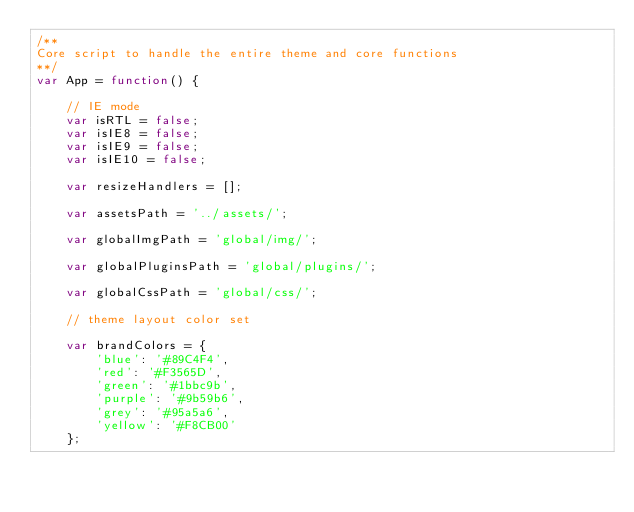<code> <loc_0><loc_0><loc_500><loc_500><_JavaScript_>/**
Core script to handle the entire theme and core functions
**/
var App = function() {

    // IE mode
    var isRTL = false;
    var isIE8 = false;
    var isIE9 = false;
    var isIE10 = false;

    var resizeHandlers = [];

    var assetsPath = '../assets/';

    var globalImgPath = 'global/img/';

    var globalPluginsPath = 'global/plugins/';

    var globalCssPath = 'global/css/';

    // theme layout color set

    var brandColors = {
        'blue': '#89C4F4',
        'red': '#F3565D',
        'green': '#1bbc9b',
        'purple': '#9b59b6',
        'grey': '#95a5a6',
        'yellow': '#F8CB00'
    };
</code> 